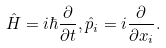<formula> <loc_0><loc_0><loc_500><loc_500>\hat { H } = i \hbar { \frac { \partial } { \partial t } } , \hat { p } _ { i } = { i } \frac { \partial } { \partial x _ { i } } .</formula> 